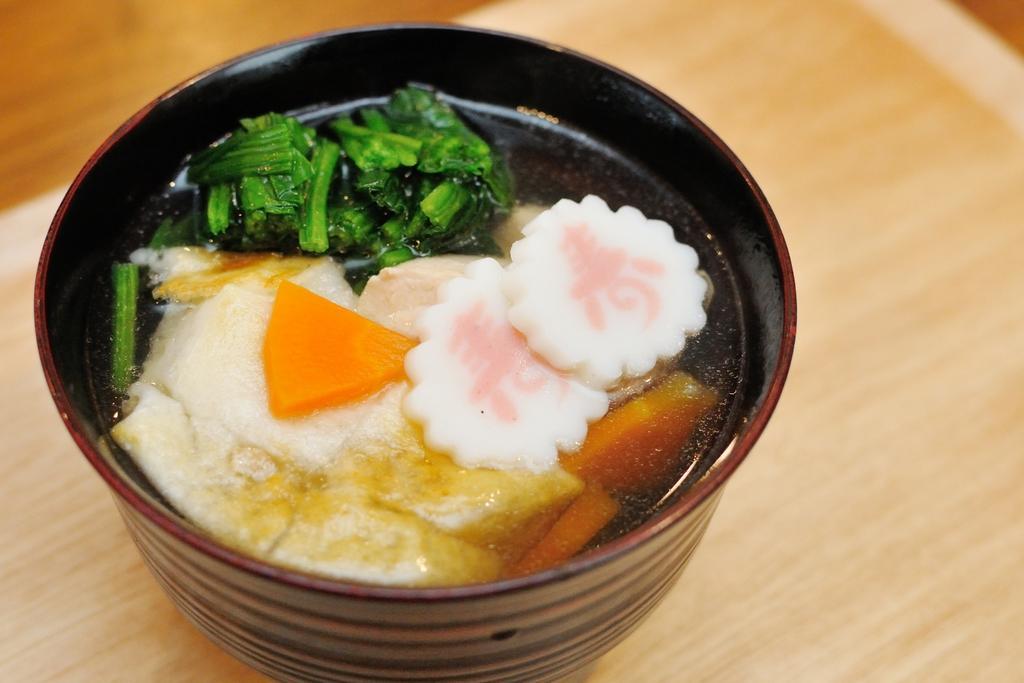Can you describe this image briefly? In this image we can see a bowl in which food item is there. In the background of the image is in blue. 